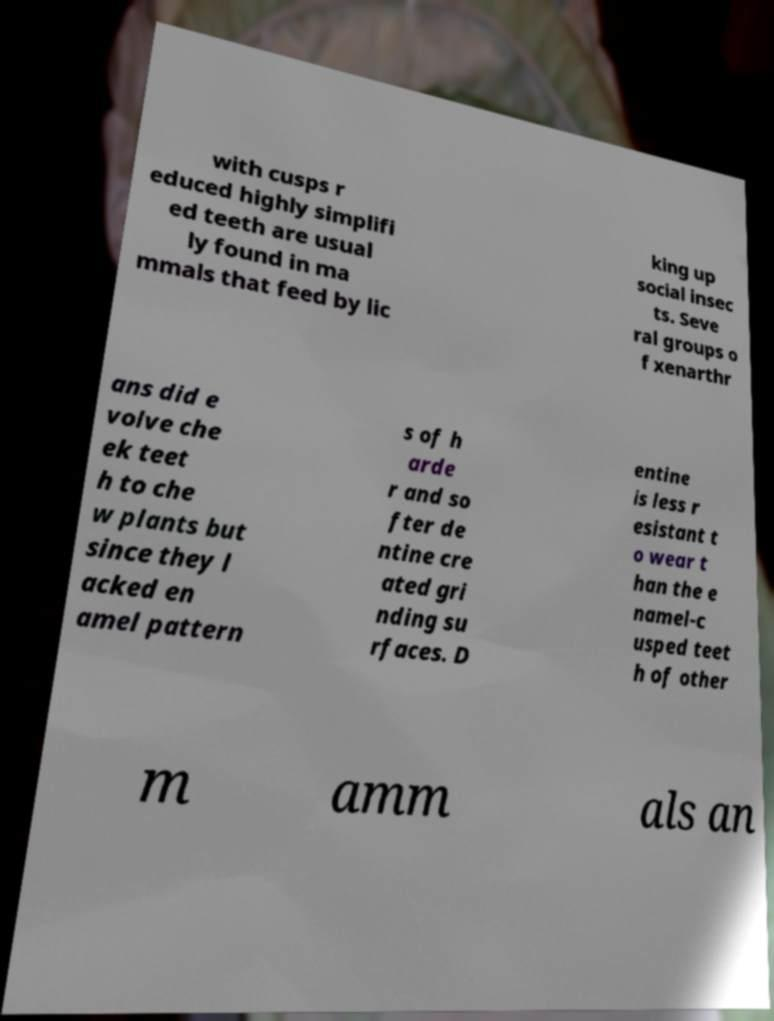What messages or text are displayed in this image? I need them in a readable, typed format. with cusps r educed highly simplifi ed teeth are usual ly found in ma mmals that feed by lic king up social insec ts. Seve ral groups o f xenarthr ans did e volve che ek teet h to che w plants but since they l acked en amel pattern s of h arde r and so fter de ntine cre ated gri nding su rfaces. D entine is less r esistant t o wear t han the e namel-c usped teet h of other m amm als an 